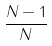<formula> <loc_0><loc_0><loc_500><loc_500>\frac { N - 1 } { N }</formula> 